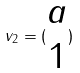Convert formula to latex. <formula><loc_0><loc_0><loc_500><loc_500>v _ { 2 } = ( \begin{matrix} a \\ 1 \end{matrix} )</formula> 